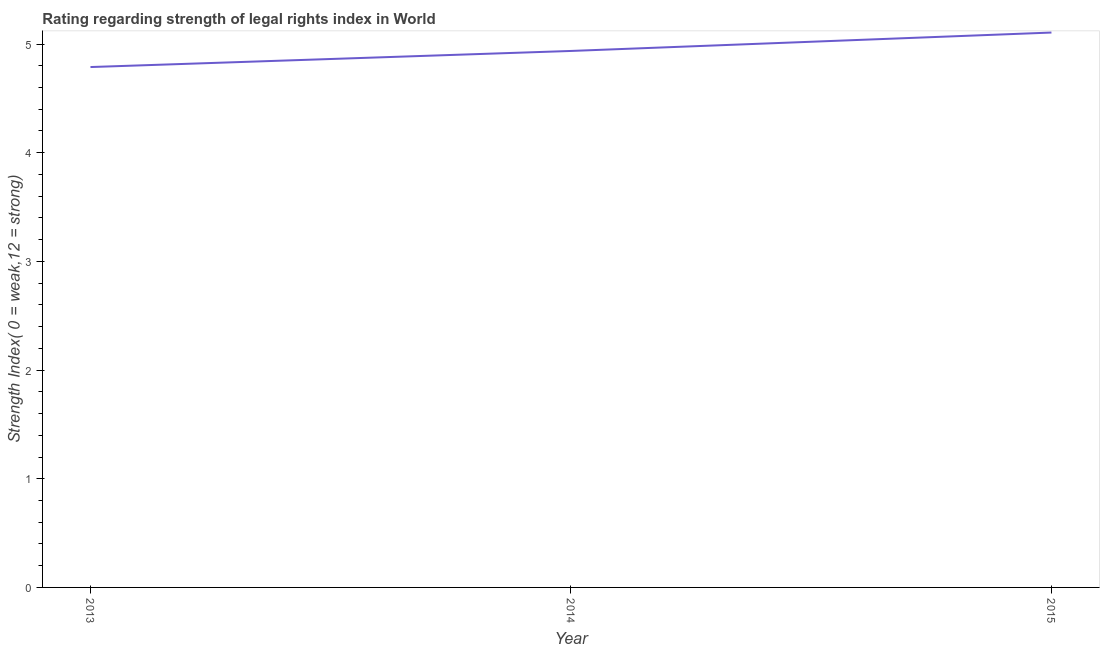What is the strength of legal rights index in 2013?
Give a very brief answer. 4.79. Across all years, what is the maximum strength of legal rights index?
Provide a succinct answer. 5.11. Across all years, what is the minimum strength of legal rights index?
Offer a terse response. 4.79. In which year was the strength of legal rights index maximum?
Provide a short and direct response. 2015. What is the sum of the strength of legal rights index?
Give a very brief answer. 14.83. What is the difference between the strength of legal rights index in 2013 and 2015?
Offer a very short reply. -0.32. What is the average strength of legal rights index per year?
Keep it short and to the point. 4.94. What is the median strength of legal rights index?
Your response must be concise. 4.94. Do a majority of the years between 2013 and 2014 (inclusive) have strength of legal rights index greater than 1.2 ?
Your answer should be very brief. Yes. What is the ratio of the strength of legal rights index in 2014 to that in 2015?
Make the answer very short. 0.97. What is the difference between the highest and the second highest strength of legal rights index?
Make the answer very short. 0.17. Is the sum of the strength of legal rights index in 2013 and 2015 greater than the maximum strength of legal rights index across all years?
Give a very brief answer. Yes. What is the difference between the highest and the lowest strength of legal rights index?
Offer a terse response. 0.32. How many lines are there?
Provide a short and direct response. 1. How many years are there in the graph?
Give a very brief answer. 3. Are the values on the major ticks of Y-axis written in scientific E-notation?
Give a very brief answer. No. Does the graph contain grids?
Make the answer very short. No. What is the title of the graph?
Your response must be concise. Rating regarding strength of legal rights index in World. What is the label or title of the Y-axis?
Your response must be concise. Strength Index( 0 = weak,12 = strong). What is the Strength Index( 0 = weak,12 = strong) in 2013?
Your answer should be compact. 4.79. What is the Strength Index( 0 = weak,12 = strong) in 2014?
Your answer should be very brief. 4.94. What is the Strength Index( 0 = weak,12 = strong) in 2015?
Your answer should be compact. 5.11. What is the difference between the Strength Index( 0 = weak,12 = strong) in 2013 and 2014?
Your answer should be compact. -0.15. What is the difference between the Strength Index( 0 = weak,12 = strong) in 2013 and 2015?
Your answer should be compact. -0.32. What is the difference between the Strength Index( 0 = weak,12 = strong) in 2014 and 2015?
Your answer should be compact. -0.17. What is the ratio of the Strength Index( 0 = weak,12 = strong) in 2013 to that in 2015?
Keep it short and to the point. 0.94. 